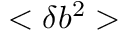Convert formula to latex. <formula><loc_0><loc_0><loc_500><loc_500>< \delta b ^ { 2 } ></formula> 